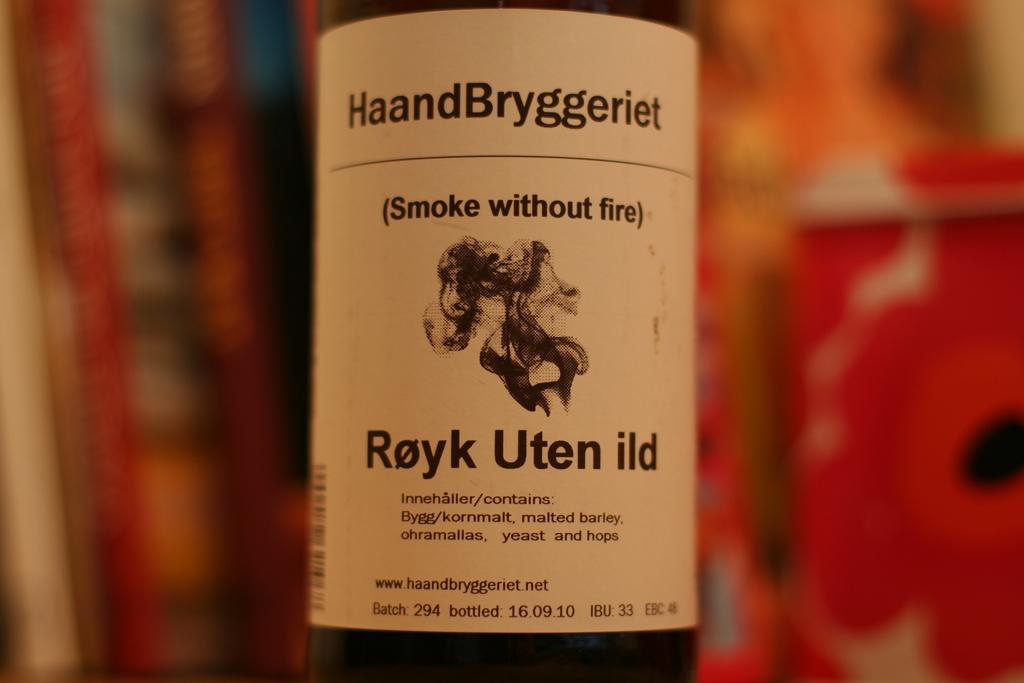What does it say in parentheses on the bottle?
Ensure brevity in your answer.  Smoke without fire. 